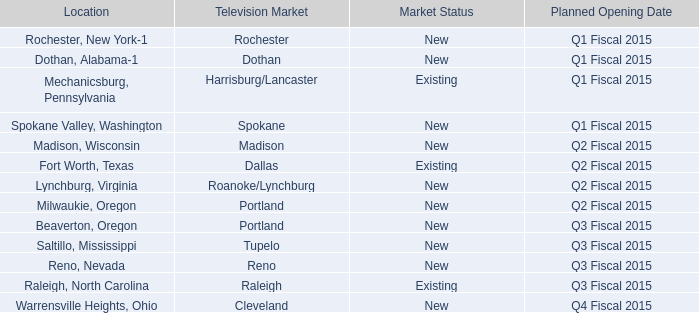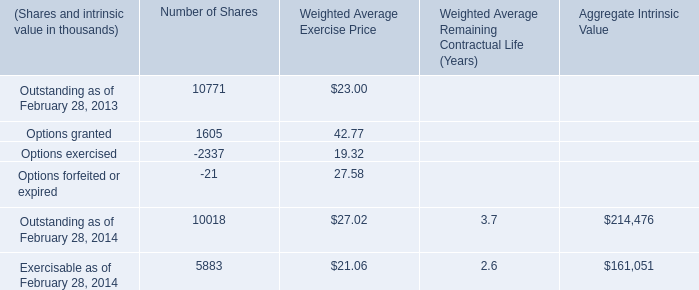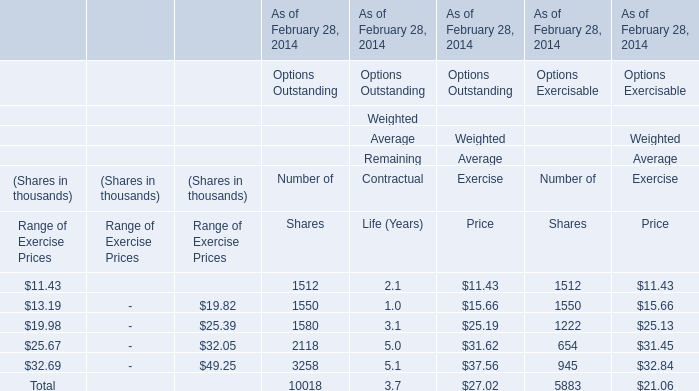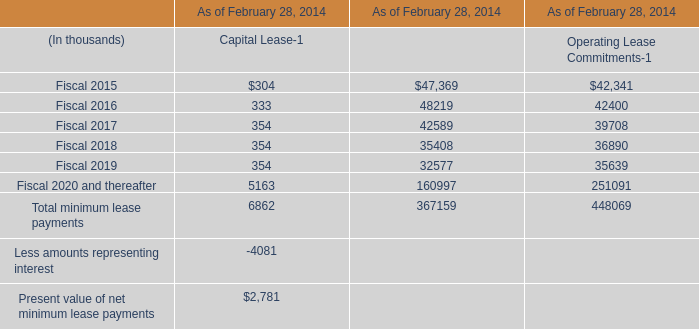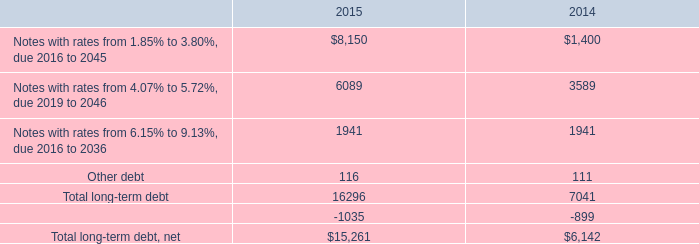What's the greatest value of Weighted Average Exercise Price in terms of Options Outstanding As of February 28, 2014? 
Answer: 37.56. 